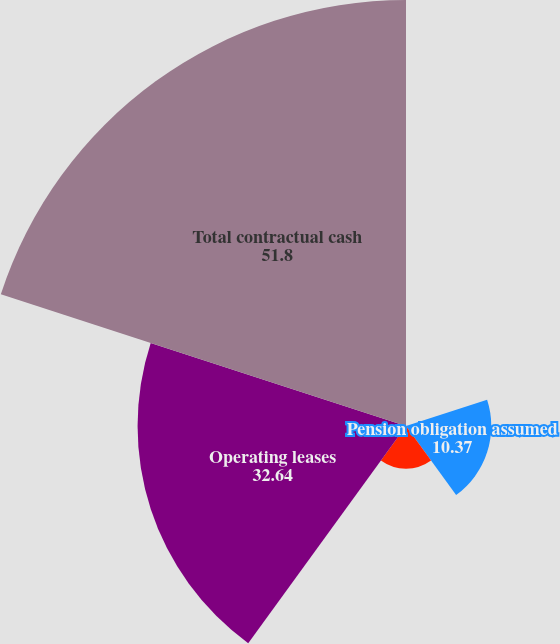Convert chart to OTSL. <chart><loc_0><loc_0><loc_500><loc_500><pie_chart><fcel>Debt<fcel>Pension obligation assumed<fcel>Capital lease obligation<fcel>Operating leases<fcel>Total contractual cash<nl><fcel>0.01%<fcel>10.37%<fcel>5.19%<fcel>32.64%<fcel>51.8%<nl></chart> 